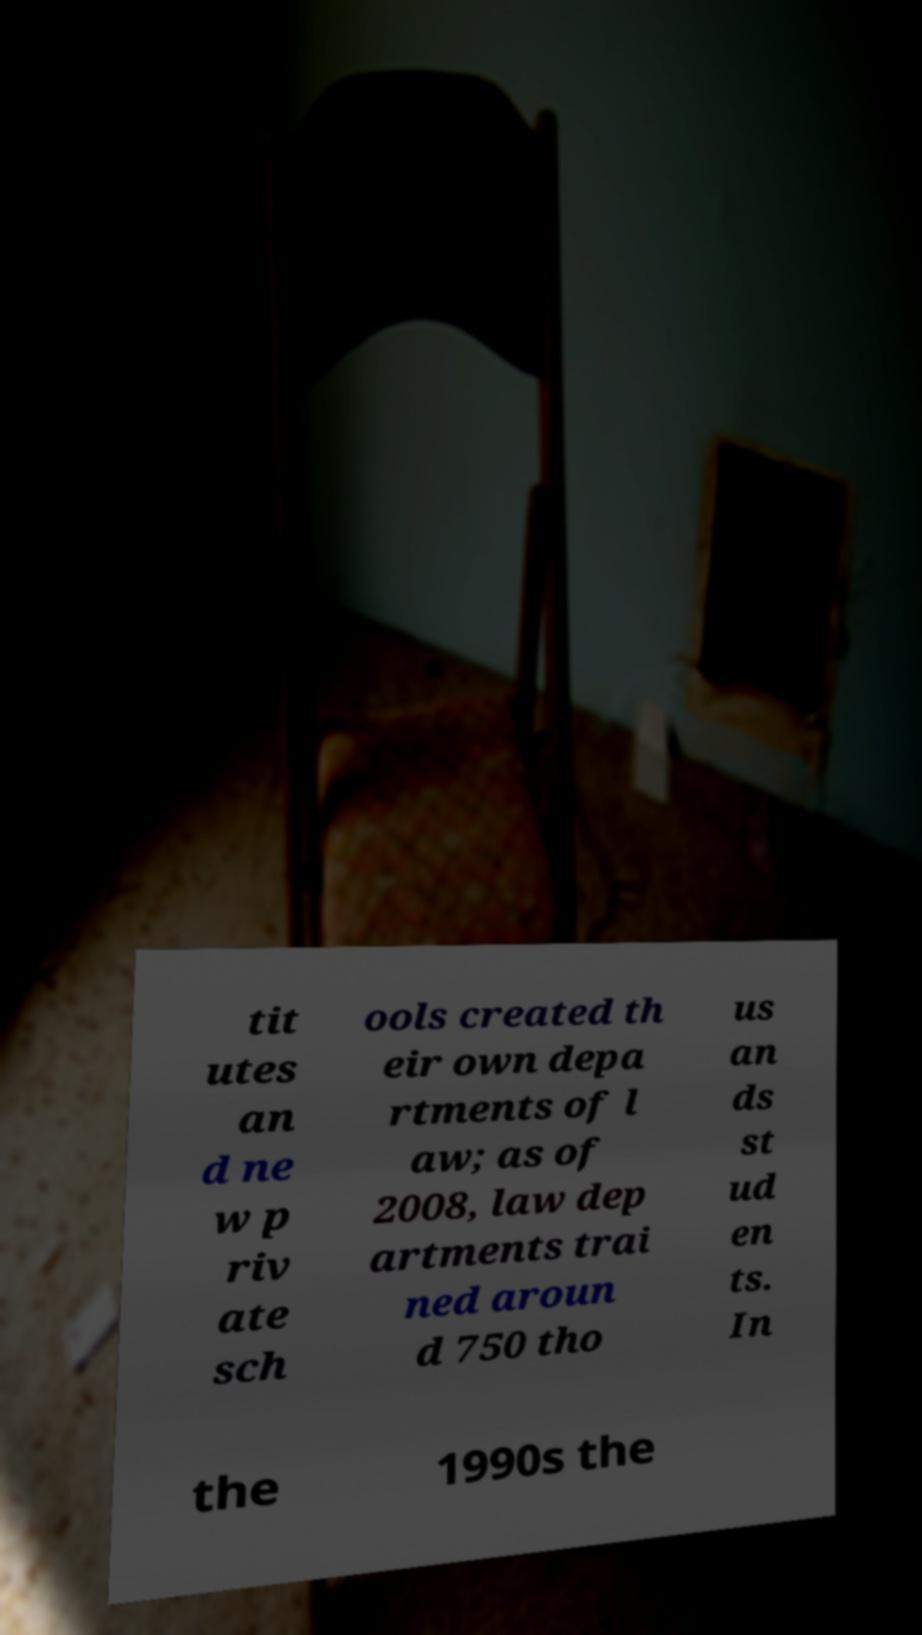Could you extract and type out the text from this image? tit utes an d ne w p riv ate sch ools created th eir own depa rtments of l aw; as of 2008, law dep artments trai ned aroun d 750 tho us an ds st ud en ts. In the 1990s the 